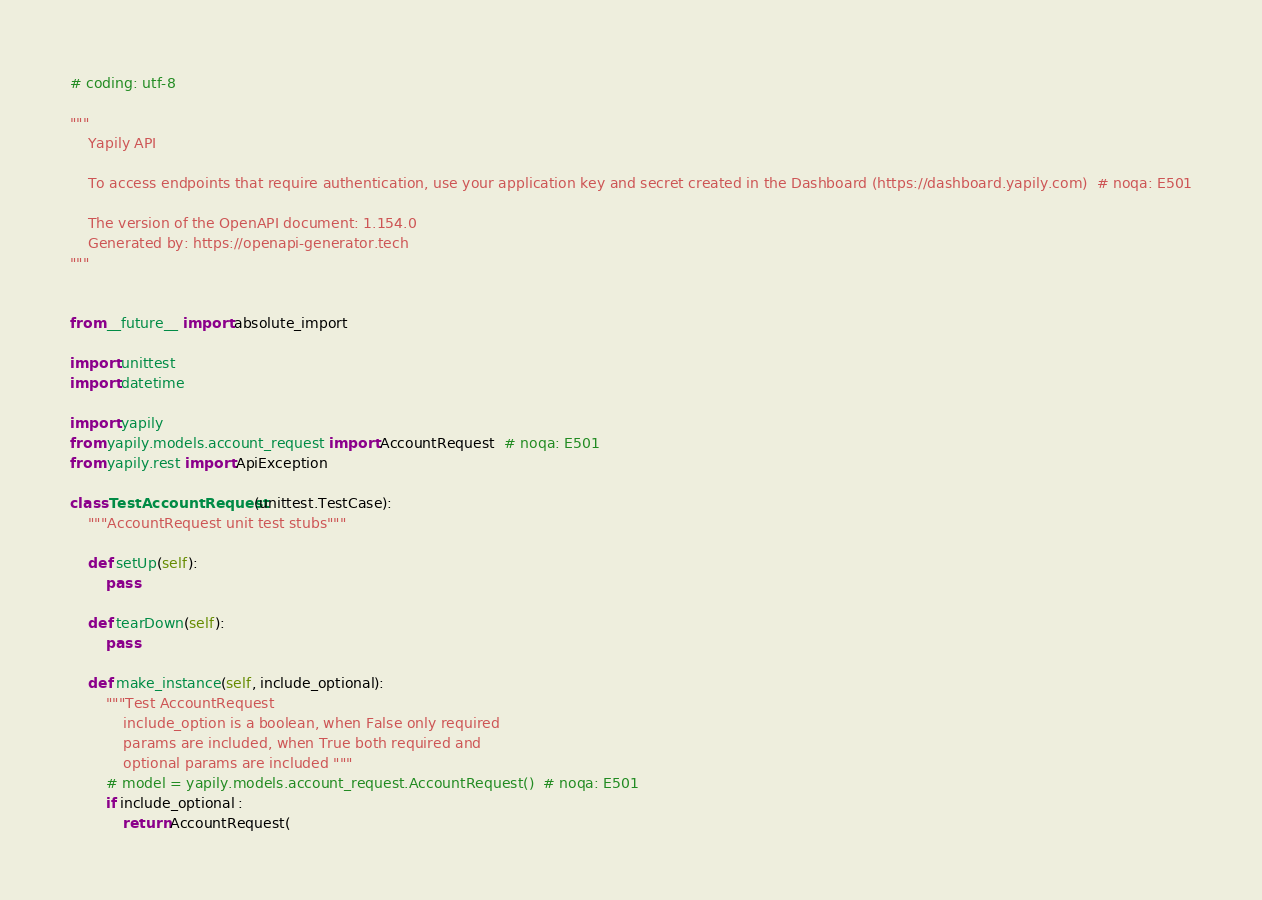<code> <loc_0><loc_0><loc_500><loc_500><_Python_># coding: utf-8

"""
    Yapily API

    To access endpoints that require authentication, use your application key and secret created in the Dashboard (https://dashboard.yapily.com)  # noqa: E501

    The version of the OpenAPI document: 1.154.0
    Generated by: https://openapi-generator.tech
"""


from __future__ import absolute_import

import unittest
import datetime

import yapily
from yapily.models.account_request import AccountRequest  # noqa: E501
from yapily.rest import ApiException

class TestAccountRequest(unittest.TestCase):
    """AccountRequest unit test stubs"""

    def setUp(self):
        pass

    def tearDown(self):
        pass

    def make_instance(self, include_optional):
        """Test AccountRequest
            include_option is a boolean, when False only required
            params are included, when True both required and
            optional params are included """
        # model = yapily.models.account_request.AccountRequest()  # noqa: E501
        if include_optional :
            return AccountRequest(</code> 